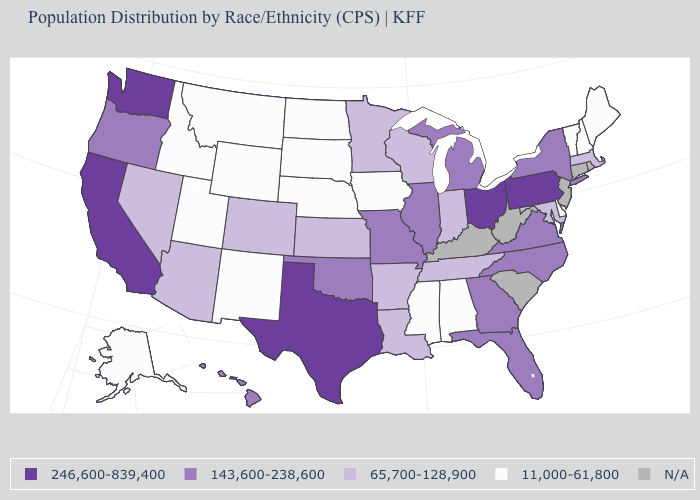Name the states that have a value in the range 11,000-61,800?
Be succinct. Alabama, Alaska, Delaware, Idaho, Iowa, Maine, Mississippi, Montana, Nebraska, New Hampshire, New Mexico, North Dakota, South Dakota, Utah, Vermont, Wyoming. Which states have the lowest value in the MidWest?
Give a very brief answer. Iowa, Nebraska, North Dakota, South Dakota. What is the value of South Carolina?
Answer briefly. N/A. What is the highest value in the USA?
Be succinct. 246,600-839,400. Which states have the lowest value in the South?
Quick response, please. Alabama, Delaware, Mississippi. What is the value of Kentucky?
Short answer required. N/A. Name the states that have a value in the range 11,000-61,800?
Short answer required. Alabama, Alaska, Delaware, Idaho, Iowa, Maine, Mississippi, Montana, Nebraska, New Hampshire, New Mexico, North Dakota, South Dakota, Utah, Vermont, Wyoming. What is the value of Oklahoma?
Be succinct. 143,600-238,600. Does the first symbol in the legend represent the smallest category?
Write a very short answer. No. Name the states that have a value in the range 143,600-238,600?
Concise answer only. Florida, Georgia, Hawaii, Illinois, Michigan, Missouri, New York, North Carolina, Oklahoma, Oregon, Virginia. Name the states that have a value in the range 65,700-128,900?
Give a very brief answer. Arizona, Arkansas, Colorado, Indiana, Kansas, Louisiana, Maryland, Massachusetts, Minnesota, Nevada, Tennessee, Wisconsin. Which states hav the highest value in the West?
Answer briefly. California, Washington. Does Nebraska have the lowest value in the USA?
Give a very brief answer. Yes. How many symbols are there in the legend?
Give a very brief answer. 5. Among the states that border North Carolina , does Tennessee have the highest value?
Answer briefly. No. 